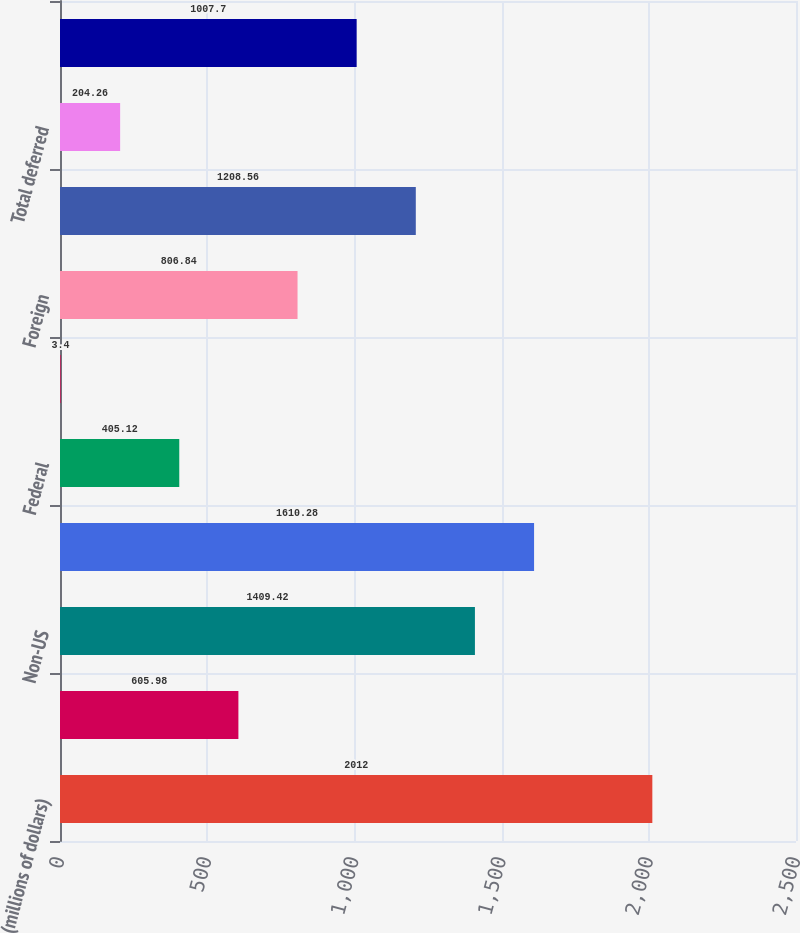<chart> <loc_0><loc_0><loc_500><loc_500><bar_chart><fcel>(millions of dollars)<fcel>US<fcel>Non-US<fcel>Total<fcel>Federal<fcel>State<fcel>Foreign<fcel>Total current<fcel>Total deferred<fcel>Total provision for income<nl><fcel>2012<fcel>605.98<fcel>1409.42<fcel>1610.28<fcel>405.12<fcel>3.4<fcel>806.84<fcel>1208.56<fcel>204.26<fcel>1007.7<nl></chart> 